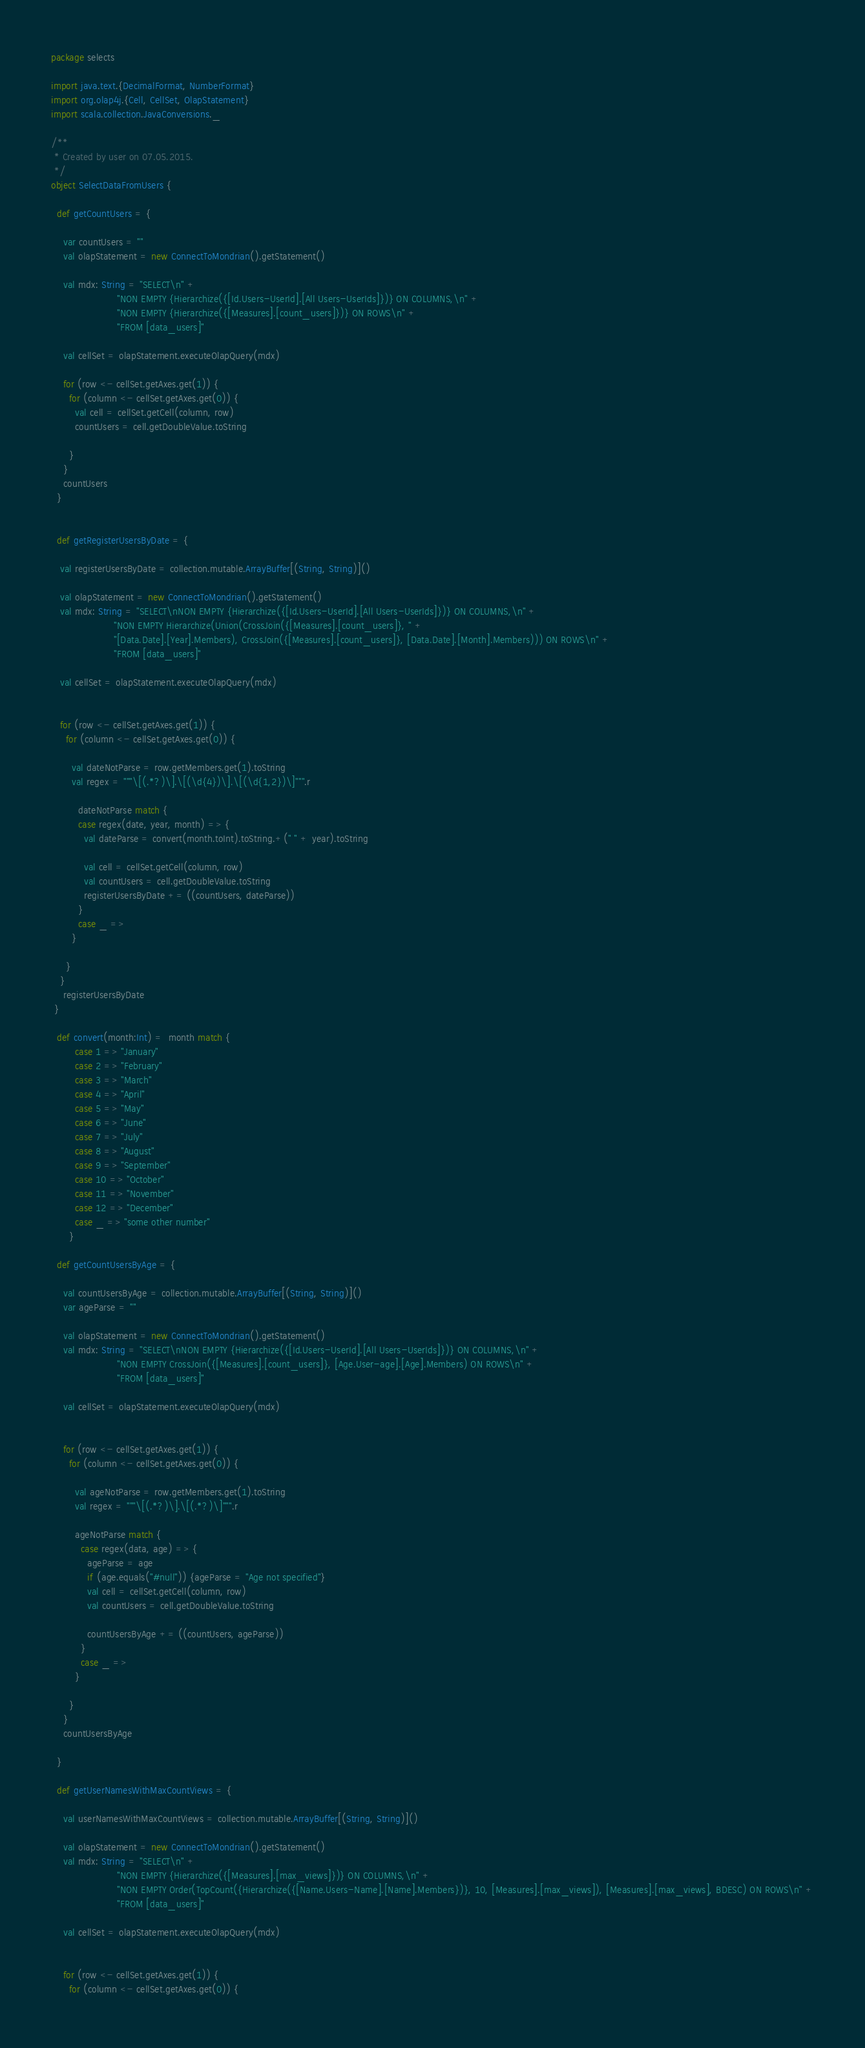<code> <loc_0><loc_0><loc_500><loc_500><_Scala_>package selects

import java.text.{DecimalFormat, NumberFormat}
import org.olap4j.{Cell, CellSet, OlapStatement}
import scala.collection.JavaConversions._

/**
 * Created by user on 07.05.2015.
 */
object SelectDataFromUsers {

  def getCountUsers = {

    var countUsers = ""
    val olapStatement = new ConnectToMondrian().getStatement()

    val mdx: String = "SELECT\n" +
                      "NON EMPTY {Hierarchize({[Id.Users-UserId].[All Users-UserIds]})} ON COLUMNS,\n" +
                      "NON EMPTY {Hierarchize({[Measures].[count_users]})} ON ROWS\n" +
                      "FROM [data_users]"

    val cellSet = olapStatement.executeOlapQuery(mdx)

    for (row <- cellSet.getAxes.get(1)) {
      for (column <- cellSet.getAxes.get(0)) {
        val cell = cellSet.getCell(column, row)
        countUsers = cell.getDoubleValue.toString

      }
    }
    countUsers
  }


  def getRegisterUsersByDate = {

   val registerUsersByDate = collection.mutable.ArrayBuffer[(String, String)]()

   val olapStatement = new ConnectToMondrian().getStatement()
   val mdx: String = "SELECT\nNON EMPTY {Hierarchize({[Id.Users-UserId].[All Users-UserIds]})} ON COLUMNS,\n" +
                     "NON EMPTY Hierarchize(Union(CrossJoin({[Measures].[count_users]}, " +
                     "[Data.Date].[Year].Members), CrossJoin({[Measures].[count_users]}, [Data.Date].[Month].Members))) ON ROWS\n" +
                     "FROM [data_users]"

   val cellSet = olapStatement.executeOlapQuery(mdx)


   for (row <- cellSet.getAxes.get(1)) {
     for (column <- cellSet.getAxes.get(0)) {

       val dateNotParse = row.getMembers.get(1).toString
       val regex = """\[(.*?)\].\[(\d{4})\].\[(\d{1,2})\]""".r

         dateNotParse match {
         case regex(date, year, month) => {
           val dateParse = convert(month.toInt).toString.+(" " + year).toString

           val cell = cellSet.getCell(column, row)
           val countUsers = cell.getDoubleValue.toString
           registerUsersByDate += ((countUsers, dateParse))
         }
         case _ =>
       }

     }
   }
    registerUsersByDate
 }

  def convert(month:Int) =  month match {
        case 1 => "January"
        case 2 => "February"
        case 3 => "March"
        case 4 => "April"
        case 5 => "May"
        case 6 => "June"
        case 7 => "July"
        case 8 => "August"
        case 9 => "September"
        case 10 => "October"
        case 11 => "November"
        case 12 => "December"
        case _ => "some other number"
      }

  def getCountUsersByAge = {

    val countUsersByAge = collection.mutable.ArrayBuffer[(String, String)]()
    var ageParse = ""

    val olapStatement = new ConnectToMondrian().getStatement()
    val mdx: String = "SELECT\nNON EMPTY {Hierarchize({[Id.Users-UserId].[All Users-UserIds]})} ON COLUMNS,\n" +
                      "NON EMPTY CrossJoin({[Measures].[count_users]}, [Age.User-age].[Age].Members) ON ROWS\n" +
                      "FROM [data_users]"

    val cellSet = olapStatement.executeOlapQuery(mdx)


    for (row <- cellSet.getAxes.get(1)) {
      for (column <- cellSet.getAxes.get(0)) {

        val ageNotParse = row.getMembers.get(1).toString
        val regex = """\[(.*?)\].\[(.*?)\]""".r

        ageNotParse match {
          case regex(data, age) => {
            ageParse = age
            if (age.equals("#null")) {ageParse = "Age not specified"}
            val cell = cellSet.getCell(column, row)
            val countUsers = cell.getDoubleValue.toString

            countUsersByAge += ((countUsers, ageParse))
          }
          case _ =>
        }

      }
    }
    countUsersByAge

  }

  def getUserNamesWithMaxCountViews = {

    val userNamesWithMaxCountViews = collection.mutable.ArrayBuffer[(String, String)]()

    val olapStatement = new ConnectToMondrian().getStatement()
    val mdx: String = "SELECT\n" +
                      "NON EMPTY {Hierarchize({[Measures].[max_views]})} ON COLUMNS,\n" +
                      "NON EMPTY Order(TopCount({Hierarchize({[Name.Users-Name].[Name].Members})}, 10, [Measures].[max_views]), [Measures].[max_views], BDESC) ON ROWS\n" +
                      "FROM [data_users]"

    val cellSet = olapStatement.executeOlapQuery(mdx)


    for (row <- cellSet.getAxes.get(1)) {
      for (column <- cellSet.getAxes.get(0)) {
</code> 